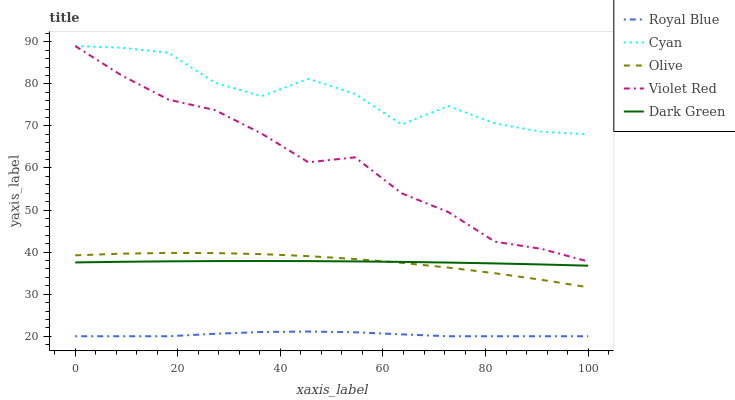Does Royal Blue have the minimum area under the curve?
Answer yes or no. Yes. Does Cyan have the maximum area under the curve?
Answer yes or no. Yes. Does Violet Red have the minimum area under the curve?
Answer yes or no. No. Does Violet Red have the maximum area under the curve?
Answer yes or no. No. Is Dark Green the smoothest?
Answer yes or no. Yes. Is Cyan the roughest?
Answer yes or no. Yes. Is Royal Blue the smoothest?
Answer yes or no. No. Is Royal Blue the roughest?
Answer yes or no. No. Does Violet Red have the lowest value?
Answer yes or no. No. Does Cyan have the highest value?
Answer yes or no. Yes. Does Royal Blue have the highest value?
Answer yes or no. No. Is Royal Blue less than Cyan?
Answer yes or no. Yes. Is Cyan greater than Royal Blue?
Answer yes or no. Yes. Does Dark Green intersect Olive?
Answer yes or no. Yes. Is Dark Green less than Olive?
Answer yes or no. No. Is Dark Green greater than Olive?
Answer yes or no. No. Does Royal Blue intersect Cyan?
Answer yes or no. No. 